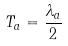<formula> <loc_0><loc_0><loc_500><loc_500>T _ { a } = \frac { \lambda _ { a } } { 2 }</formula> 